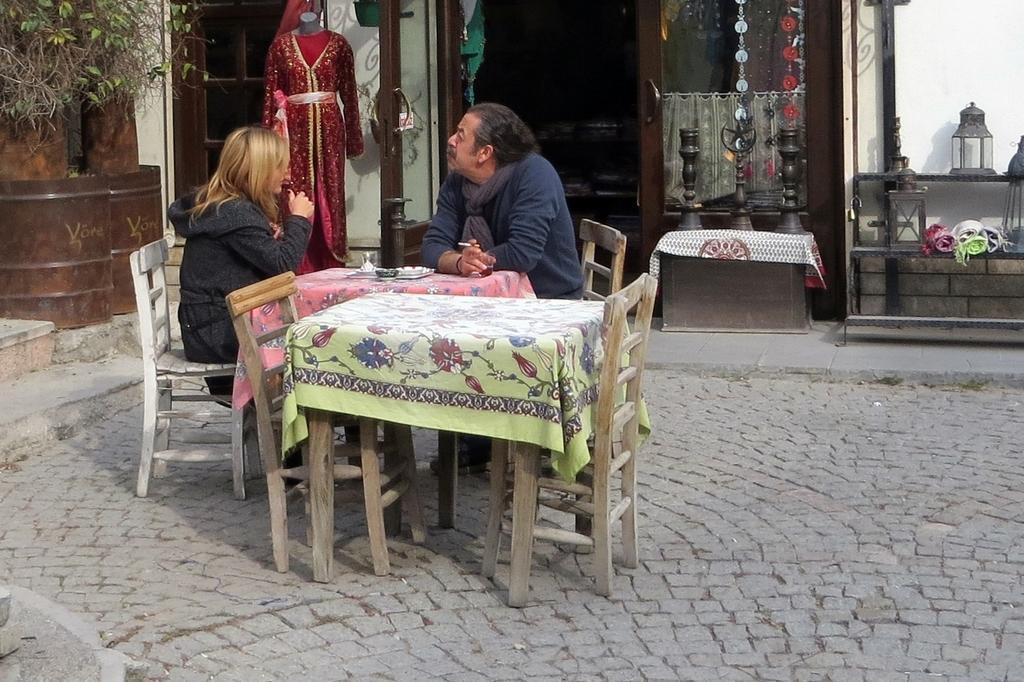Describe this image in one or two sentences. In the picture we can see a man and a woman sitting on the chairs near the table, background we can see a dresses, plants, shop and a pole. 